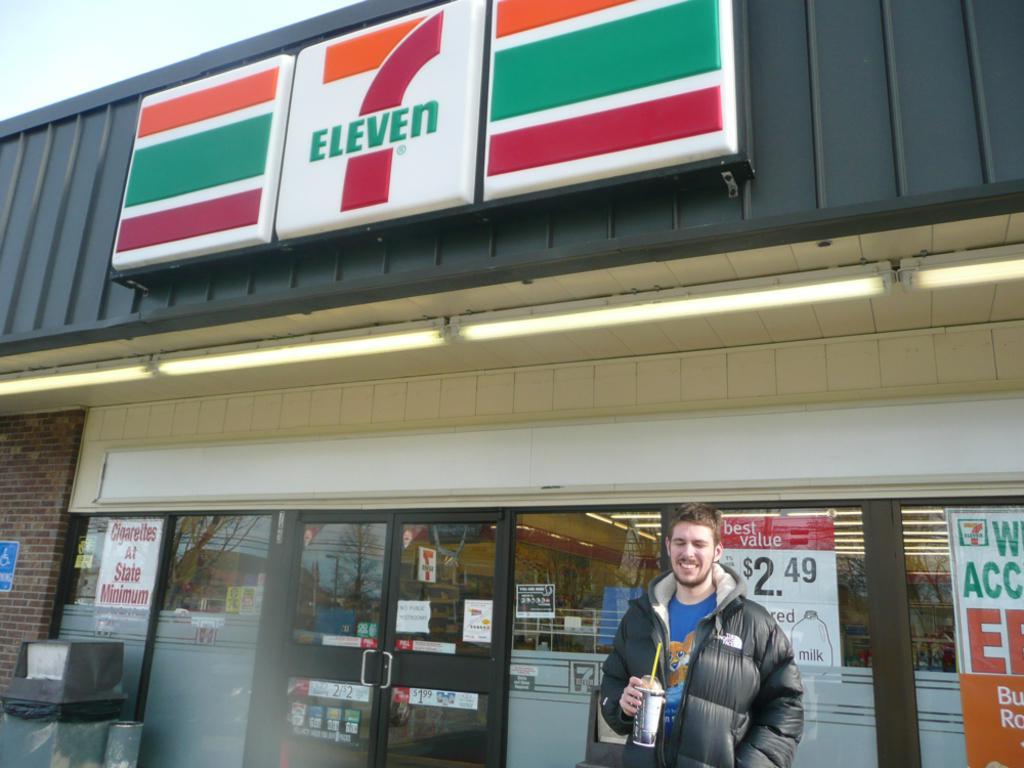In one or two sentences, can you explain what this image depicts? In this image there is a man standing by holding the coffee cup. Behind him there is a store. On the left side there is a glass door. At the top there are lights. There are so many poster sticked to the glass. On the left side bottom there is a dustbin. At the top there is a hoarding. 